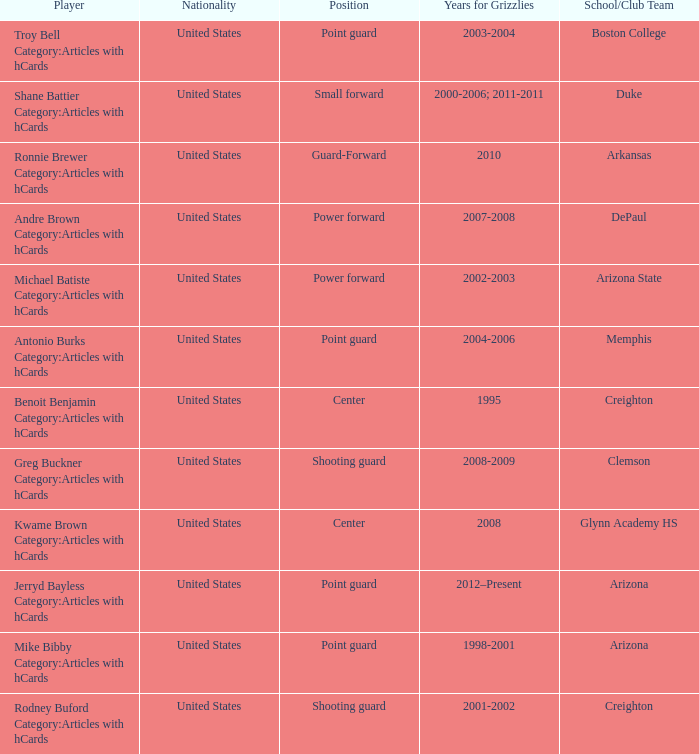Which Player has Years for Grizzlies of 2002-2003? Michael Batiste Category:Articles with hCards. 